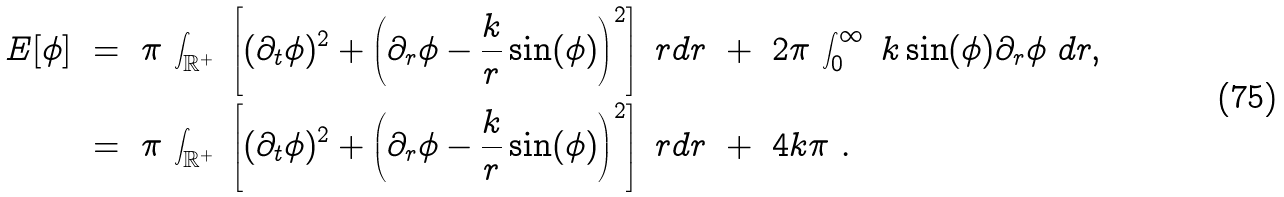Convert formula to latex. <formula><loc_0><loc_0><loc_500><loc_500>E [ \phi ] \ & = \ \pi \, \int _ { \mathbb { R } ^ { + } } \ \left [ ( \partial _ { t } \phi ) ^ { 2 } + \left ( \partial _ { r } \phi - \frac { k } { r } \sin ( \phi ) \right ) ^ { 2 } \right ] \ r d r \ + \ 2 \pi \, \int _ { 0 } ^ { \infty } \ k \sin ( \phi ) \partial _ { r } \phi \ d r , \\ & = \ \pi \, \int _ { \mathbb { R } ^ { + } } \ \left [ ( \partial _ { t } \phi ) ^ { 2 } + \left ( \partial _ { r } \phi - \frac { k } { r } \sin ( \phi ) \right ) ^ { 2 } \right ] \ r d r \ + \ 4 k \pi \ .</formula> 